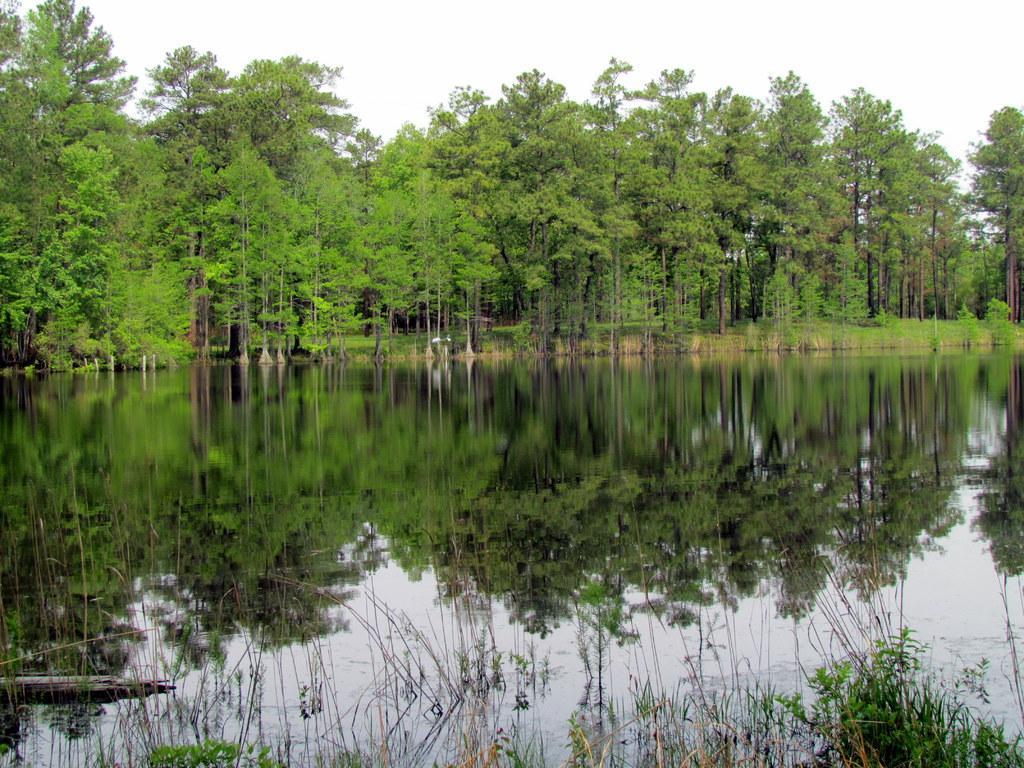Describe this image in one or two sentences. In this picture I can see trees, water and a cloudy sky. 